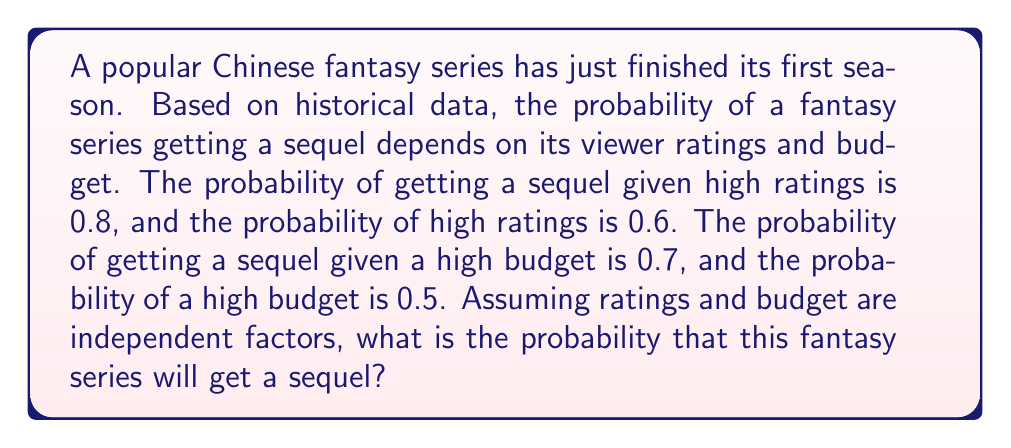Could you help me with this problem? Let's approach this step-by-step using the law of total probability:

1) Define events:
   S: The series gets a sequel
   R: The series has high ratings
   B: The series has a high budget

2) Given probabilities:
   $P(S|R) = 0.8$
   $P(R) = 0.6$
   $P(S|B) = 0.7$
   $P(B) = 0.5$

3) We need to find $P(S)$. Using the law of total probability:

   $P(S) = P(S|R)P(R) + P(S|\neg R)P(\neg R) + P(S|B)P(B) + P(S|\neg B)P(\neg B) - P(S|R \cap B)P(R \cap B)$

4) We know $P(S|R)$, $P(R)$, $P(S|B)$, and $P(B)$. We need to calculate:
   $P(\neg R) = 1 - P(R) = 1 - 0.6 = 0.4$
   $P(\neg B) = 1 - P(B) = 1 - 0.5 = 0.5$

5) We don't know $P(S|\neg R)$ and $P(S|\neg B)$, but we can estimate them as the complements of the given probabilities:
   $P(S|\neg R) \approx 1 - P(S|R) = 1 - 0.8 = 0.2$
   $P(S|\neg B) \approx 1 - P(S|B) = 1 - 0.7 = 0.3$

6) Assuming independence, $P(R \cap B) = P(R) \cdot P(B) = 0.6 \cdot 0.5 = 0.3$

7) $P(S|R \cap B)$ is not given, but we can estimate it as the maximum of $P(S|R)$ and $P(S|B)$:
   $P(S|R \cap B) \approx \max(P(S|R), P(S|B)) = \max(0.8, 0.7) = 0.8$

8) Now we can calculate:
   $P(S) = 0.8 \cdot 0.6 + 0.2 \cdot 0.4 + 0.7 \cdot 0.5 + 0.3 \cdot 0.5 - 0.8 \cdot 0.3$
   $= 0.48 + 0.08 + 0.35 + 0.15 - 0.24$
   $= 1.06 - 0.24 = 0.82$
Answer: The probability that this fantasy series will get a sequel is approximately 0.82 or 82%. 